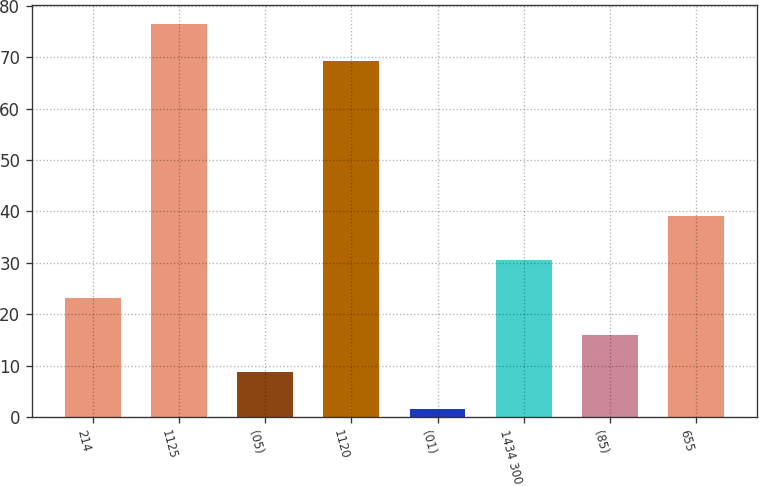Convert chart to OTSL. <chart><loc_0><loc_0><loc_500><loc_500><bar_chart><fcel>214<fcel>1125<fcel>(05)<fcel>1120<fcel>(01)<fcel>1434 300<fcel>(85)<fcel>655<nl><fcel>23.22<fcel>76.44<fcel>8.74<fcel>69.2<fcel>1.5<fcel>30.46<fcel>15.98<fcel>39.2<nl></chart> 